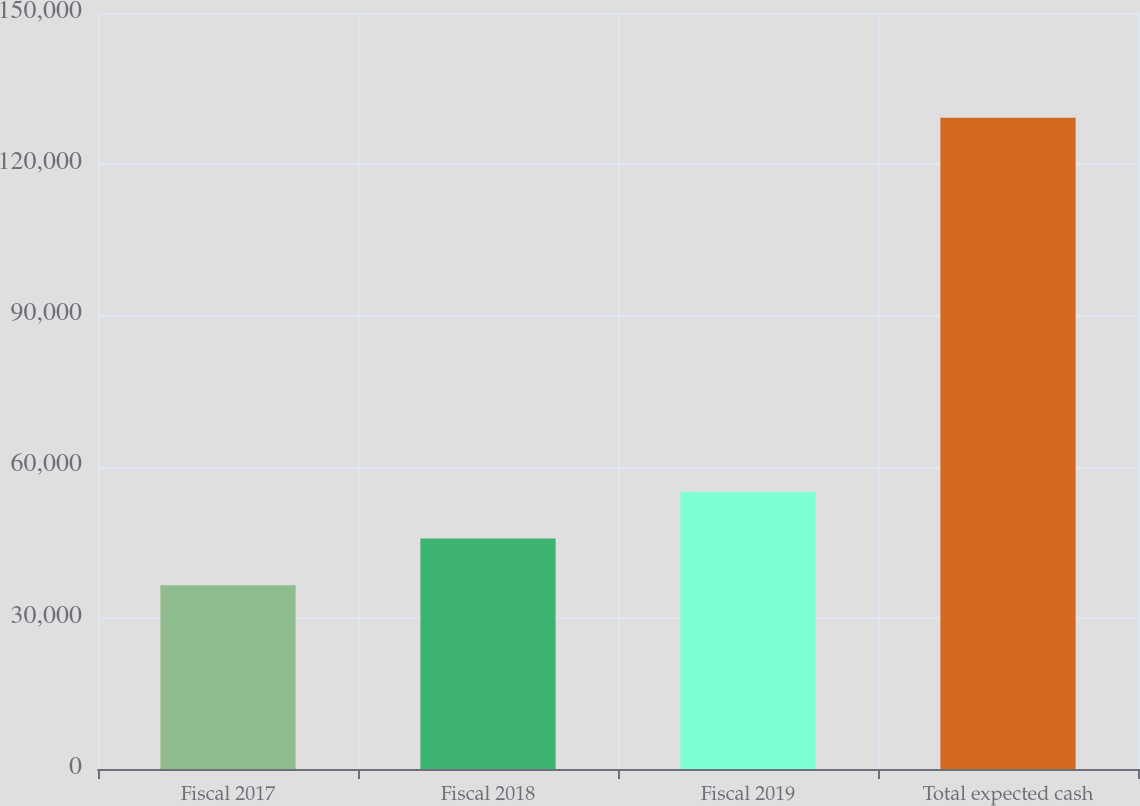Convert chart to OTSL. <chart><loc_0><loc_0><loc_500><loc_500><bar_chart><fcel>Fiscal 2017<fcel>Fiscal 2018<fcel>Fiscal 2019<fcel>Total expected cash<nl><fcel>36477<fcel>45748.7<fcel>55020.4<fcel>129194<nl></chart> 